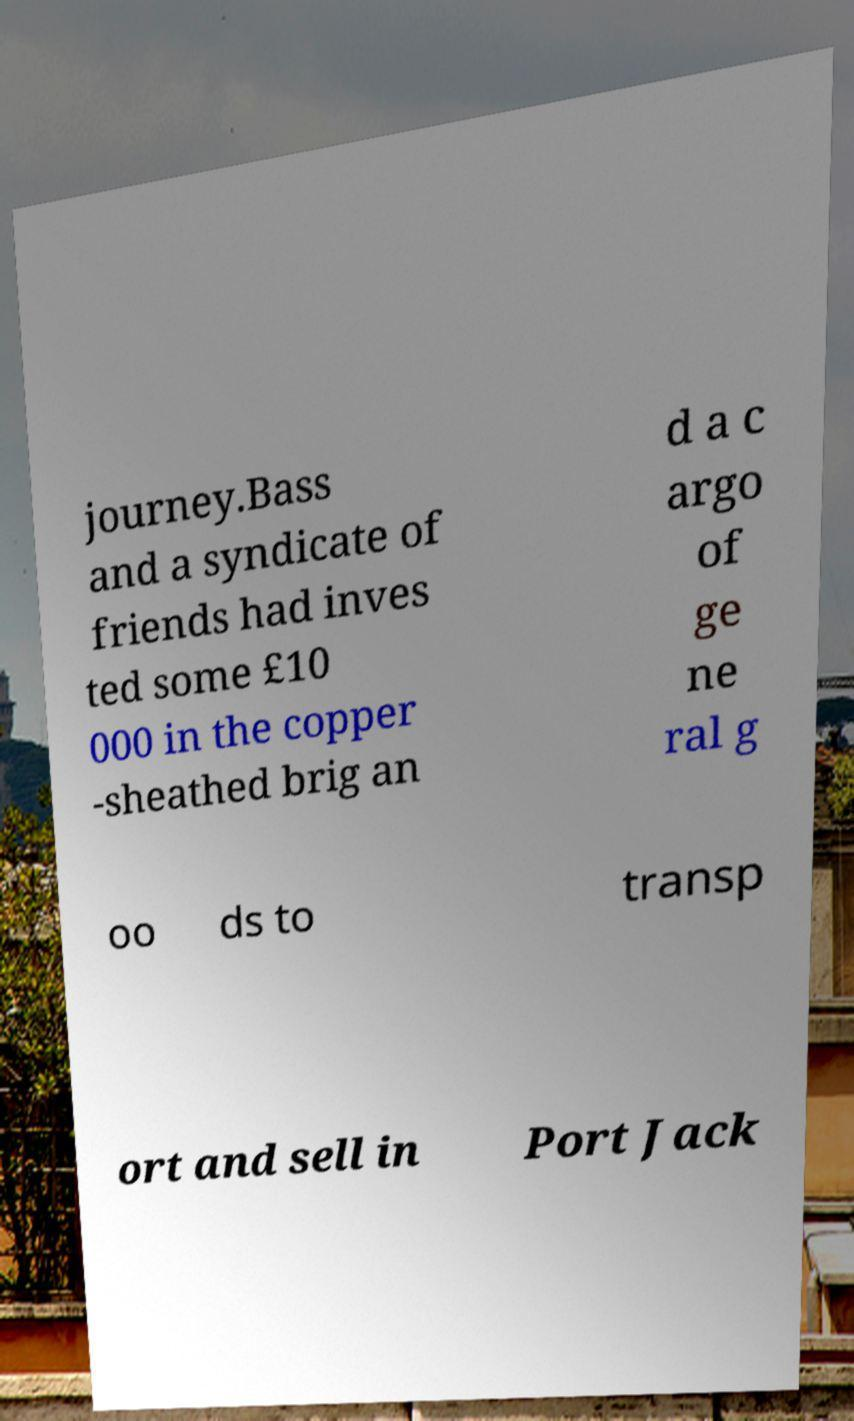Please read and relay the text visible in this image. What does it say? journey.Bass and a syndicate of friends had inves ted some £10 000 in the copper -sheathed brig an d a c argo of ge ne ral g oo ds to transp ort and sell in Port Jack 